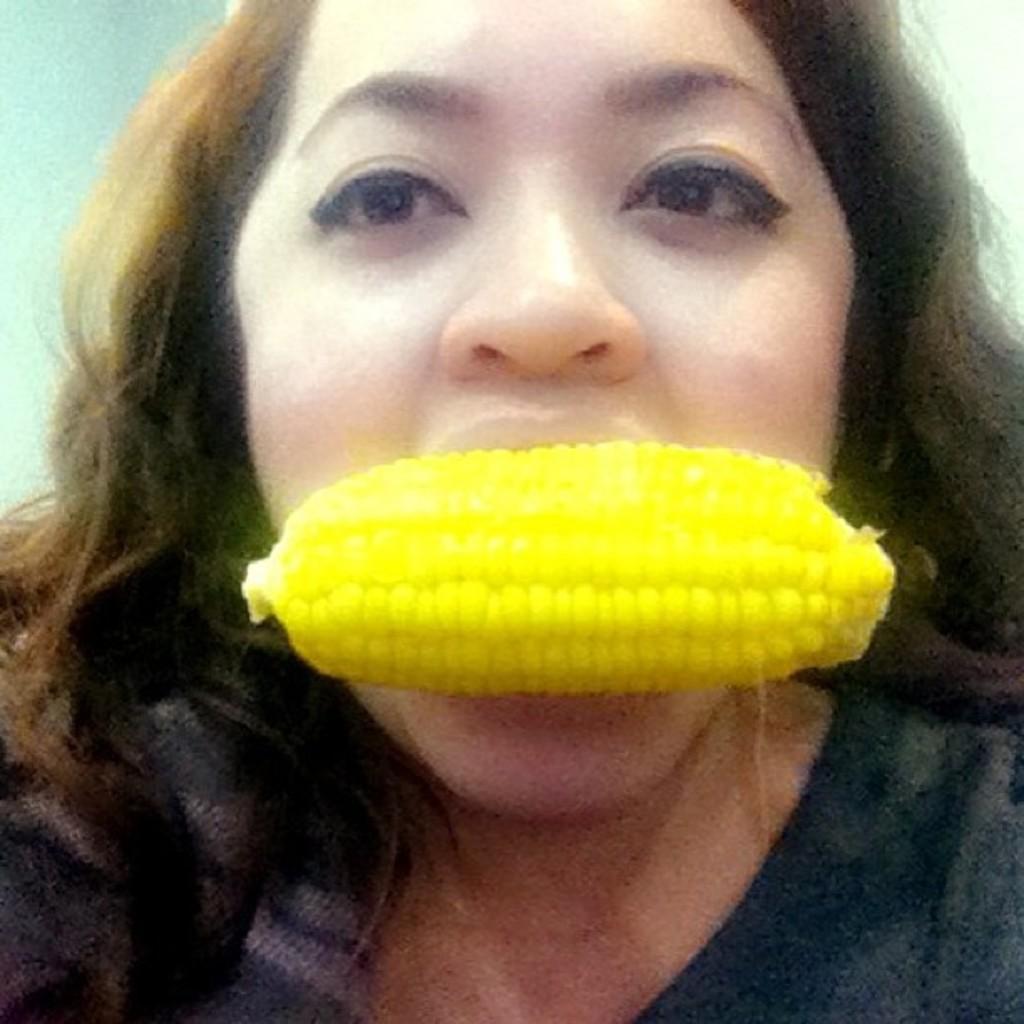Could you give a brief overview of what you see in this image? In this image there is a lady and we can see a corn in her mouth. In the background there is a wall. 